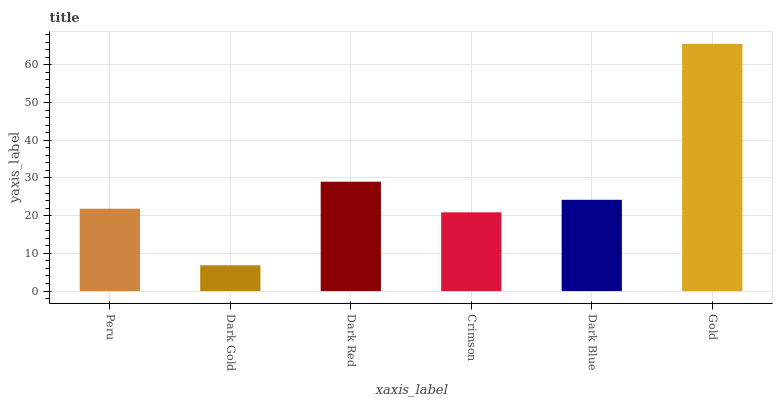Is Dark Red the minimum?
Answer yes or no. No. Is Dark Red the maximum?
Answer yes or no. No. Is Dark Red greater than Dark Gold?
Answer yes or no. Yes. Is Dark Gold less than Dark Red?
Answer yes or no. Yes. Is Dark Gold greater than Dark Red?
Answer yes or no. No. Is Dark Red less than Dark Gold?
Answer yes or no. No. Is Dark Blue the high median?
Answer yes or no. Yes. Is Peru the low median?
Answer yes or no. Yes. Is Dark Red the high median?
Answer yes or no. No. Is Dark Gold the low median?
Answer yes or no. No. 